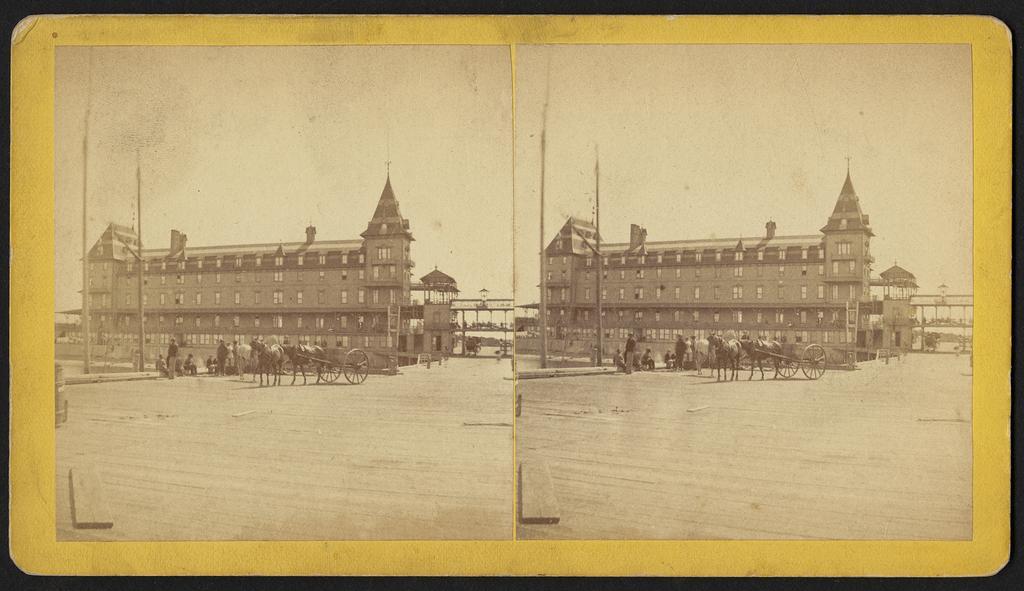In one or two sentences, can you explain what this image depicts? Here we can see two photographs on a card and both photographs are same. On the left side image we can see a building,windows,poles,horse cart,horses,few persons are standing and few persons are sitting and at the bottom there is an object on the road and on the right side image we can see the same things which are on the left side image as both the images are the same. 